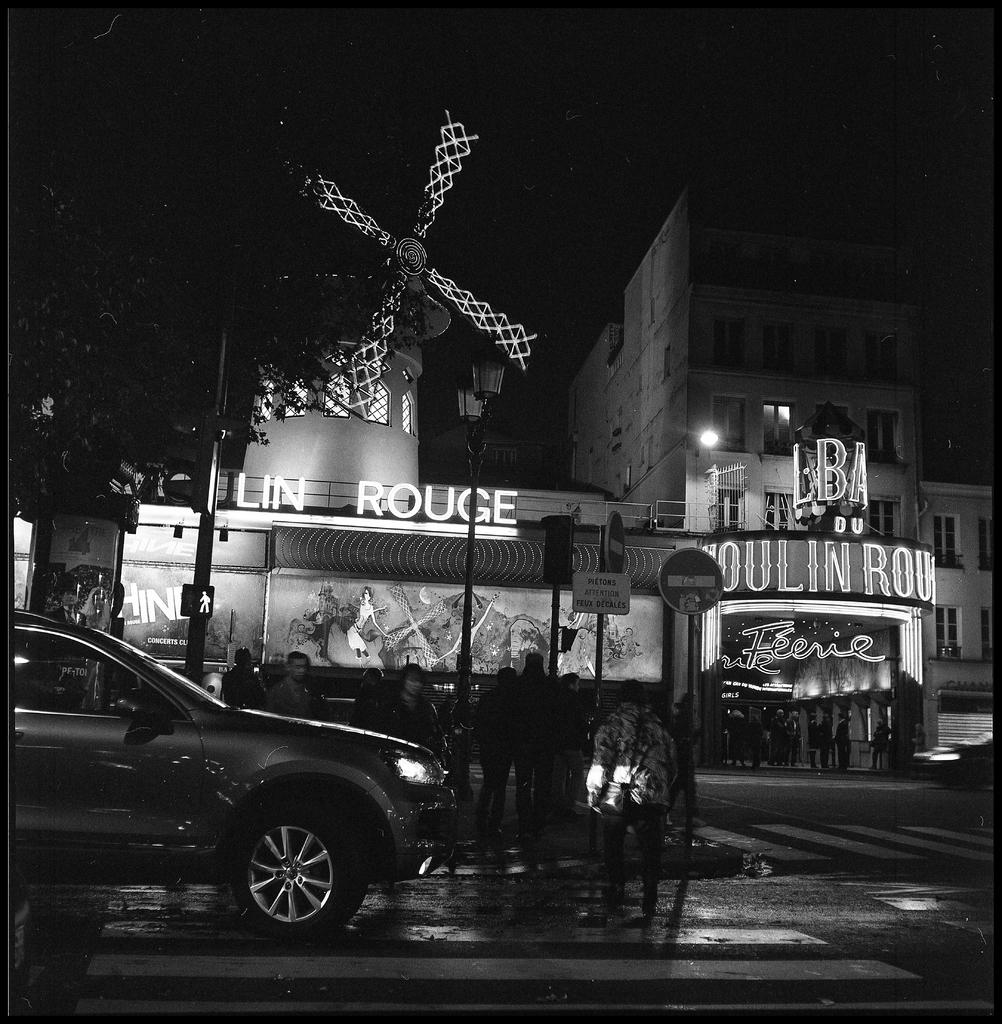What type of structures can be seen in the image? There are buildings in the image. What features can be observed on the buildings? There are windows and lights visible on the buildings. What other objects can be seen in the image? There are poles, sign boards, and boards present in the image. What is a unique feature in the image? There is a windmill in the image. Who or what else is present in the image? There are people and vehicles on the road in the image. How would you describe the overall appearance of the image? The image is dark. What type of neck accessory is being worn by the windmill in the image? There is no neck accessory present on the windmill in the image, as it is a mechanical structure. Can you see a window on the pail in the image? There is no pail present in the image, so it is not possible to determine if there is a window on it. 